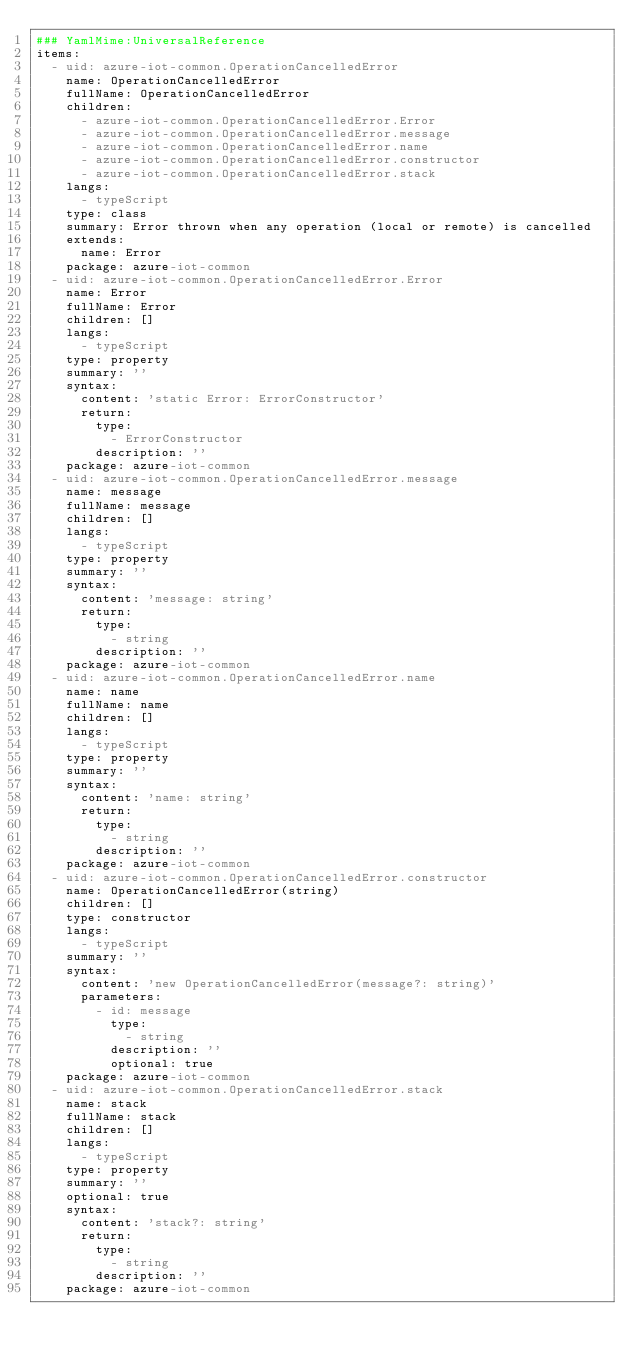<code> <loc_0><loc_0><loc_500><loc_500><_YAML_>### YamlMime:UniversalReference
items:
  - uid: azure-iot-common.OperationCancelledError
    name: OperationCancelledError
    fullName: OperationCancelledError
    children:
      - azure-iot-common.OperationCancelledError.Error
      - azure-iot-common.OperationCancelledError.message
      - azure-iot-common.OperationCancelledError.name
      - azure-iot-common.OperationCancelledError.constructor
      - azure-iot-common.OperationCancelledError.stack
    langs:
      - typeScript
    type: class
    summary: Error thrown when any operation (local or remote) is cancelled
    extends:
      name: Error
    package: azure-iot-common
  - uid: azure-iot-common.OperationCancelledError.Error
    name: Error
    fullName: Error
    children: []
    langs:
      - typeScript
    type: property
    summary: ''
    syntax:
      content: 'static Error: ErrorConstructor'
      return:
        type:
          - ErrorConstructor
        description: ''
    package: azure-iot-common
  - uid: azure-iot-common.OperationCancelledError.message
    name: message
    fullName: message
    children: []
    langs:
      - typeScript
    type: property
    summary: ''
    syntax:
      content: 'message: string'
      return:
        type:
          - string
        description: ''
    package: azure-iot-common
  - uid: azure-iot-common.OperationCancelledError.name
    name: name
    fullName: name
    children: []
    langs:
      - typeScript
    type: property
    summary: ''
    syntax:
      content: 'name: string'
      return:
        type:
          - string
        description: ''
    package: azure-iot-common
  - uid: azure-iot-common.OperationCancelledError.constructor
    name: OperationCancelledError(string)
    children: []
    type: constructor
    langs:
      - typeScript
    summary: ''
    syntax:
      content: 'new OperationCancelledError(message?: string)'
      parameters:
        - id: message
          type:
            - string
          description: ''
          optional: true
    package: azure-iot-common
  - uid: azure-iot-common.OperationCancelledError.stack
    name: stack
    fullName: stack
    children: []
    langs:
      - typeScript
    type: property
    summary: ''
    optional: true
    syntax:
      content: 'stack?: string'
      return:
        type:
          - string
        description: ''
    package: azure-iot-common
</code> 